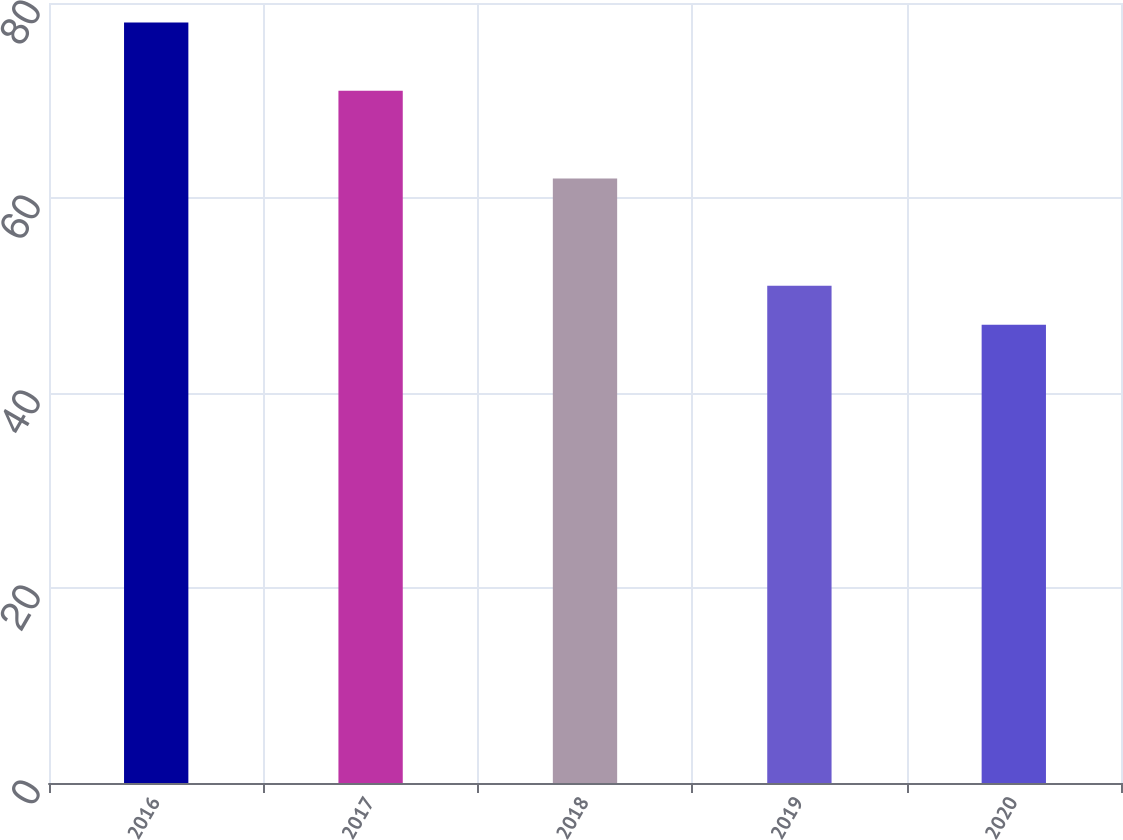Convert chart. <chart><loc_0><loc_0><loc_500><loc_500><bar_chart><fcel>2016<fcel>2017<fcel>2018<fcel>2019<fcel>2020<nl><fcel>78<fcel>71<fcel>62<fcel>51<fcel>47<nl></chart> 